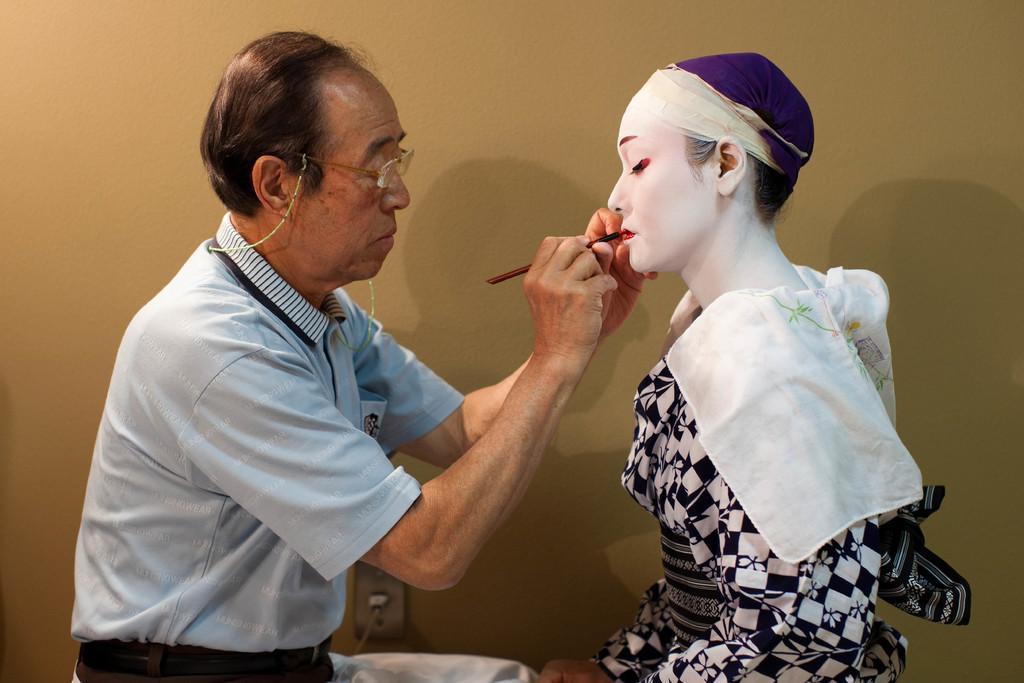Can you describe this image briefly? In this picture I can see there is a man sitting and he is holding a brush and applying lipstick to the woman sitting in front of him, he is wearing spectacles. The woman is wearing a black and white dress and there are few white clothes placed around her neck and there is a wall in the backdrop. 